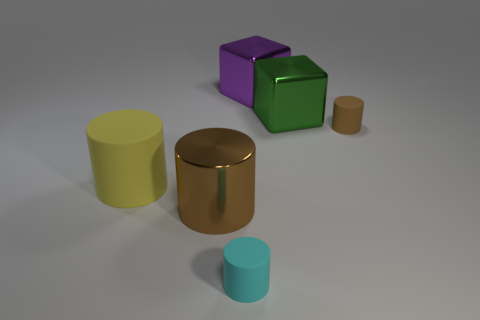How many tiny matte cylinders are the same color as the shiny cylinder?
Keep it short and to the point. 1. Are there fewer large purple shiny cubes to the left of the yellow matte cylinder than large metallic objects that are in front of the green block?
Offer a very short reply. Yes. There is a large purple metal object; are there any big metallic objects on the right side of it?
Provide a succinct answer. Yes. Are there any big purple metallic things left of the small cylinder that is in front of the small cylinder on the right side of the large green metal object?
Ensure brevity in your answer.  No. There is a tiny object that is in front of the big yellow cylinder; is its shape the same as the large matte thing?
Ensure brevity in your answer.  Yes. What color is the large object that is the same material as the tiny cyan thing?
Your response must be concise. Yellow. What number of small cyan things are the same material as the yellow thing?
Provide a short and direct response. 1. What color is the cylinder that is behind the large yellow matte cylinder that is in front of the tiny cylinder that is behind the tiny cyan rubber thing?
Provide a short and direct response. Brown. Is the cyan matte thing the same size as the green metallic thing?
Your response must be concise. No. How many things are matte cylinders that are right of the big green object or red balls?
Keep it short and to the point. 1. 